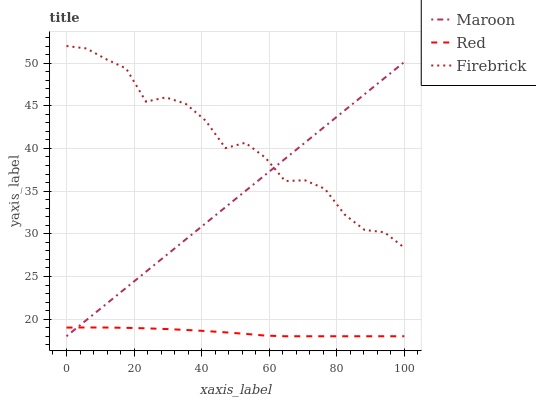Does Maroon have the minimum area under the curve?
Answer yes or no. No. Does Maroon have the maximum area under the curve?
Answer yes or no. No. Is Red the smoothest?
Answer yes or no. No. Is Red the roughest?
Answer yes or no. No. Does Maroon have the highest value?
Answer yes or no. No. Is Red less than Firebrick?
Answer yes or no. Yes. Is Firebrick greater than Red?
Answer yes or no. Yes. Does Red intersect Firebrick?
Answer yes or no. No. 